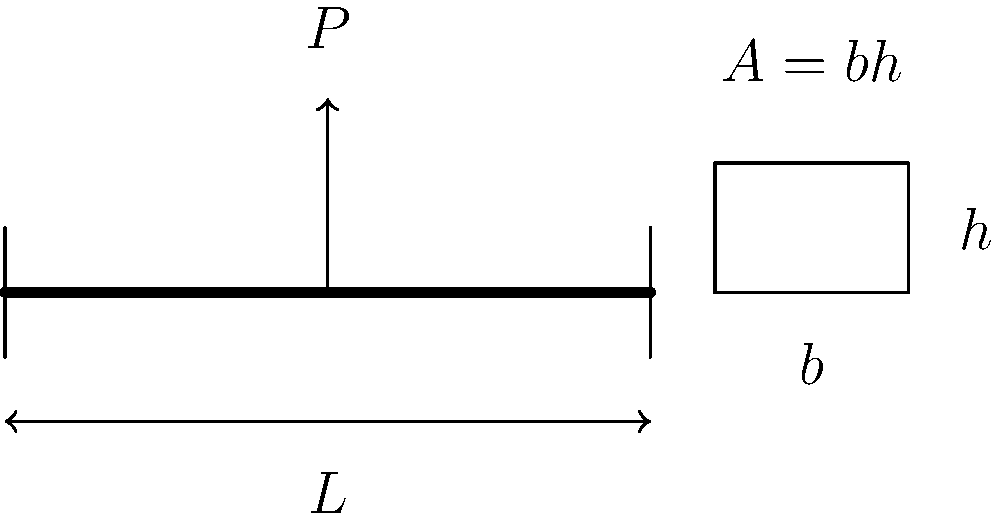A simply supported beam of length $L$ is subjected to a concentrated load $P$ at its midspan. The beam is made of a material with allowable bending stress $\sigma_{allow}$. Determine the minimum cross-sectional area $A$ required for the beam, given that the cross-section is rectangular with a width-to-height ratio of 1:2. Express your answer in terms of $P$, $L$, and $\sigma_{allow}$. Let's approach this step-by-step:

1) The maximum bending moment $M_{max}$ occurs at the midspan and is given by:
   $$M_{max} = \frac{PL}{4}$$

2) The bending stress formula is:
   $$\sigma = \frac{My}{I}$$
   where $y$ is the distance from the neutral axis to the extreme fiber, and $I$ is the moment of inertia.

3) For a rectangular cross-section, $I = \frac{bh^3}{12}$ and $y = \frac{h}{2}$

4) Given that the width-to-height ratio is 1:2, we can say $b = \frac{h}{2}$

5) Substituting these into the stress formula:
   $$\sigma_{allow} = \frac{M_{max}(\frac{h}{2})}{\frac{(\frac{h}{2})h^3}{12}}$$

6) Simplify:
   $$\sigma_{allow} = \frac{6M_{max}}{h^3}$$

7) Substitute $M_{max}$:
   $$\sigma_{allow} = \frac{6PL}{4h^3} = \frac{3PL}{2h^3}$$

8) Solve for $h$:
   $$h^3 = \frac{3PL}{2\sigma_{allow}}$$
   $$h = \sqrt[3]{\frac{3PL}{2\sigma_{allow}}}$$

9) The area $A$ is given by $A = bh = \frac{h^2}{2}$

10) Substitute the expression for $h$:
    $$A = \frac{1}{2}\left(\sqrt[3]{\frac{3PL}{2\sigma_{allow}}}\right)^2$$

11) Simplify:
    $$A = \frac{1}{2}\left(\frac{3PL}{2\sigma_{allow}}\right)^{2/3}$$
Answer: $$A = \frac{1}{2}\left(\frac{3PL}{2\sigma_{allow}}\right)^{2/3}$$ 